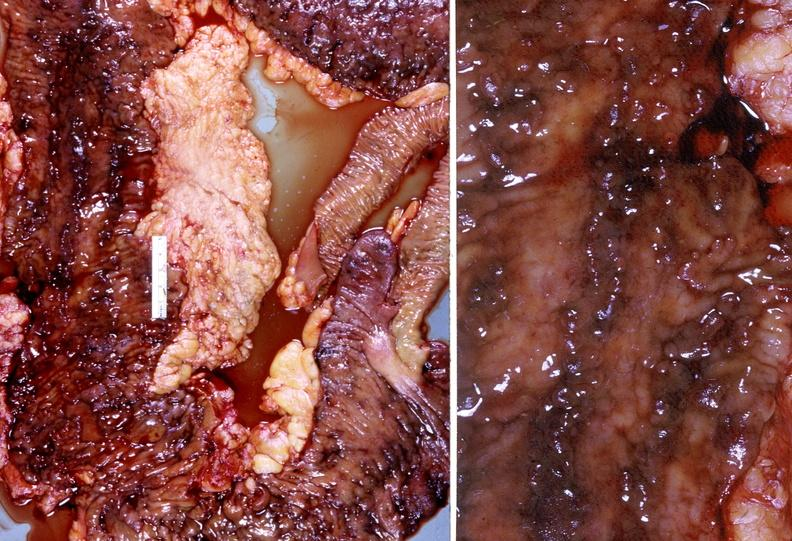s gastrointestinal present?
Answer the question using a single word or phrase. Yes 